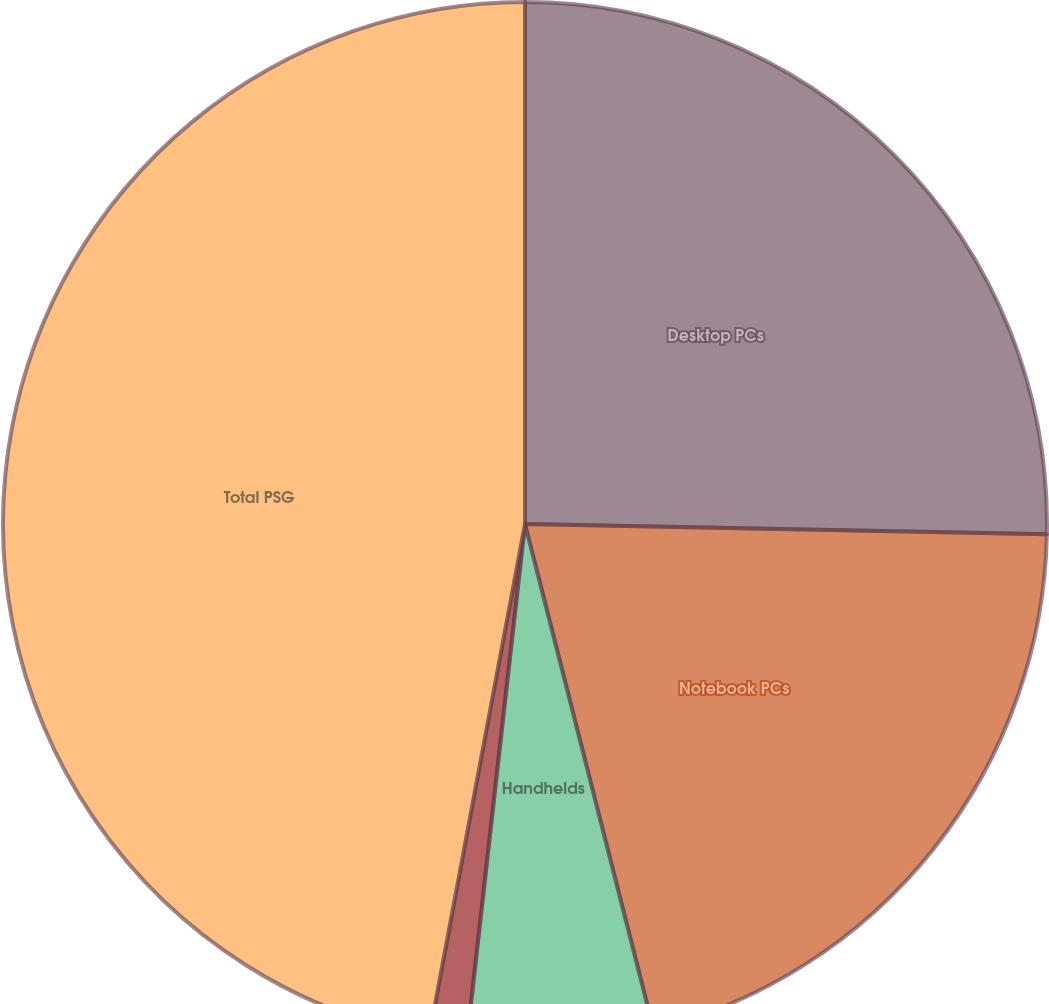<chart> <loc_0><loc_0><loc_500><loc_500><pie_chart><fcel>Desktop PCs<fcel>Notebook PCs<fcel>Handhelds<fcel>Workstations<fcel>Total PSG<nl><fcel>25.31%<fcel>20.72%<fcel>5.75%<fcel>1.16%<fcel>47.05%<nl></chart> 